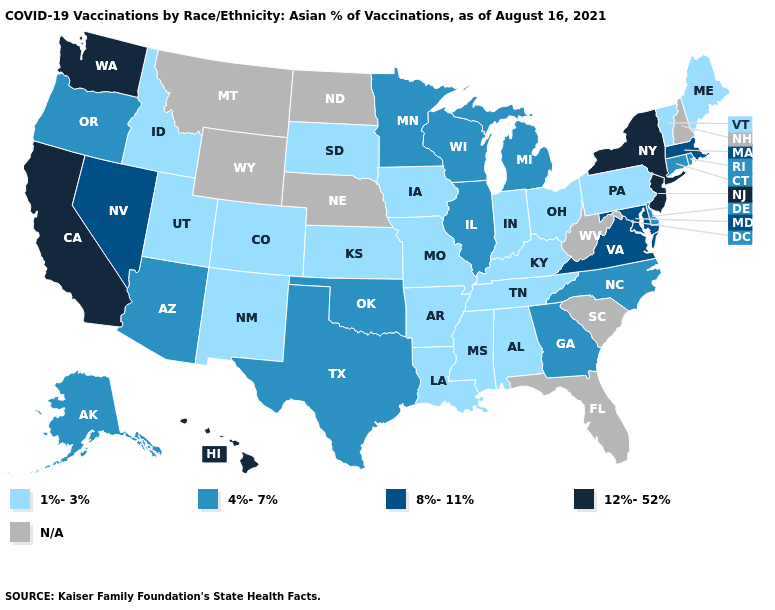Name the states that have a value in the range 1%-3%?
Quick response, please. Alabama, Arkansas, Colorado, Idaho, Indiana, Iowa, Kansas, Kentucky, Louisiana, Maine, Mississippi, Missouri, New Mexico, Ohio, Pennsylvania, South Dakota, Tennessee, Utah, Vermont. What is the value of Kentucky?
Keep it brief. 1%-3%. Does the first symbol in the legend represent the smallest category?
Write a very short answer. Yes. How many symbols are there in the legend?
Be succinct. 5. Which states have the lowest value in the USA?
Quick response, please. Alabama, Arkansas, Colorado, Idaho, Indiana, Iowa, Kansas, Kentucky, Louisiana, Maine, Mississippi, Missouri, New Mexico, Ohio, Pennsylvania, South Dakota, Tennessee, Utah, Vermont. Does the map have missing data?
Give a very brief answer. Yes. Name the states that have a value in the range 8%-11%?
Keep it brief. Maryland, Massachusetts, Nevada, Virginia. What is the value of Mississippi?
Short answer required. 1%-3%. Name the states that have a value in the range N/A?
Quick response, please. Florida, Montana, Nebraska, New Hampshire, North Dakota, South Carolina, West Virginia, Wyoming. Which states have the lowest value in the USA?
Concise answer only. Alabama, Arkansas, Colorado, Idaho, Indiana, Iowa, Kansas, Kentucky, Louisiana, Maine, Mississippi, Missouri, New Mexico, Ohio, Pennsylvania, South Dakota, Tennessee, Utah, Vermont. Which states have the highest value in the USA?
Write a very short answer. California, Hawaii, New Jersey, New York, Washington. Name the states that have a value in the range 4%-7%?
Write a very short answer. Alaska, Arizona, Connecticut, Delaware, Georgia, Illinois, Michigan, Minnesota, North Carolina, Oklahoma, Oregon, Rhode Island, Texas, Wisconsin. Among the states that border Delaware , does Pennsylvania have the highest value?
Give a very brief answer. No. Is the legend a continuous bar?
Answer briefly. No. What is the lowest value in states that border Delaware?
Be succinct. 1%-3%. 